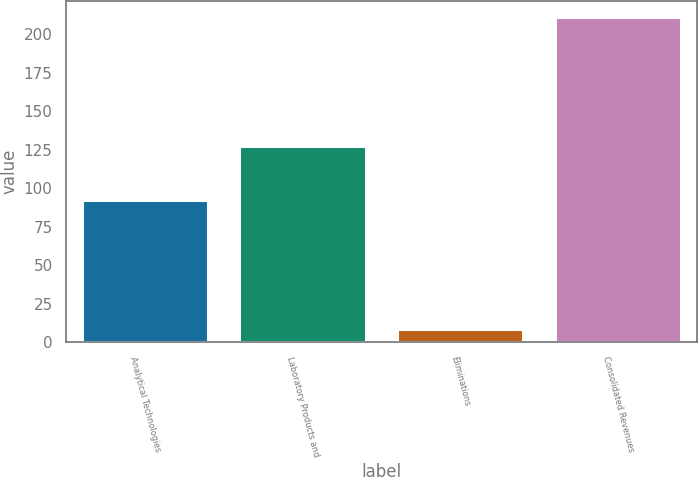<chart> <loc_0><loc_0><loc_500><loc_500><bar_chart><fcel>Analytical Technologies<fcel>Laboratory Products and<fcel>Eliminations<fcel>Consolidated Revenues<nl><fcel>92.2<fcel>127.5<fcel>8.6<fcel>211.1<nl></chart> 